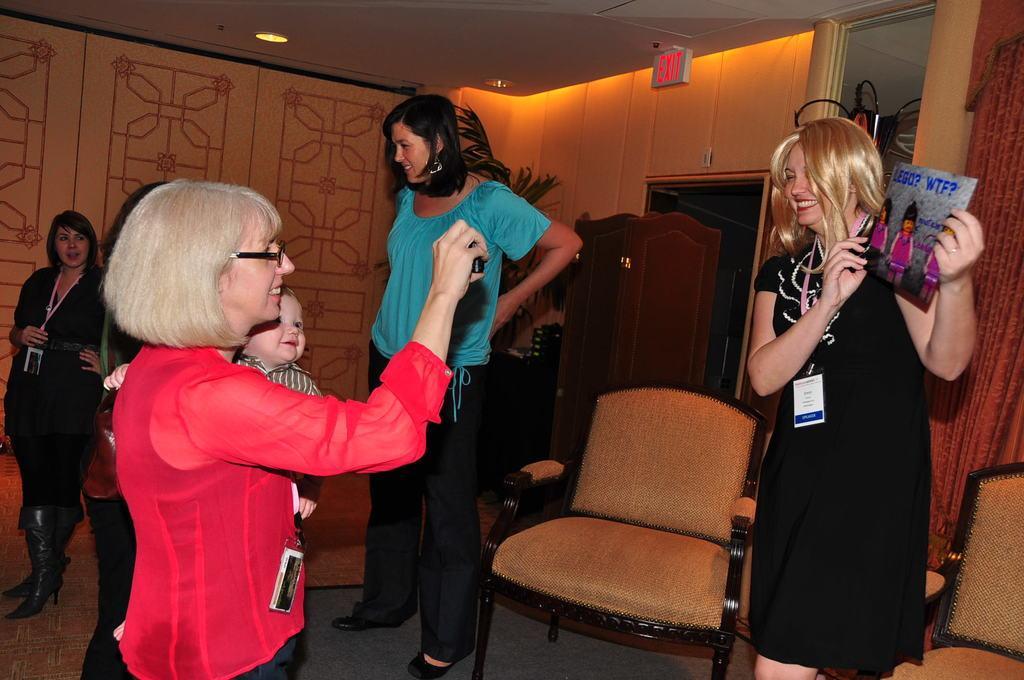Describe this image in one or two sentences. In the middle of the image a woman is standing, Behind her there is a plant. Bottom right side of the image there is a woman holding a paper. At the top of the image there is a roof and light. Bottom left side of the image a few people are standing. In the middle of the image there is a chair. 